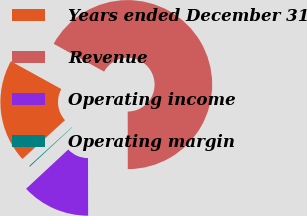Convert chart. <chart><loc_0><loc_0><loc_500><loc_500><pie_chart><fcel>Years ended December 31<fcel>Revenue<fcel>Operating income<fcel>Operating margin<nl><fcel>19.78%<fcel>66.95%<fcel>13.1%<fcel>0.17%<nl></chart> 